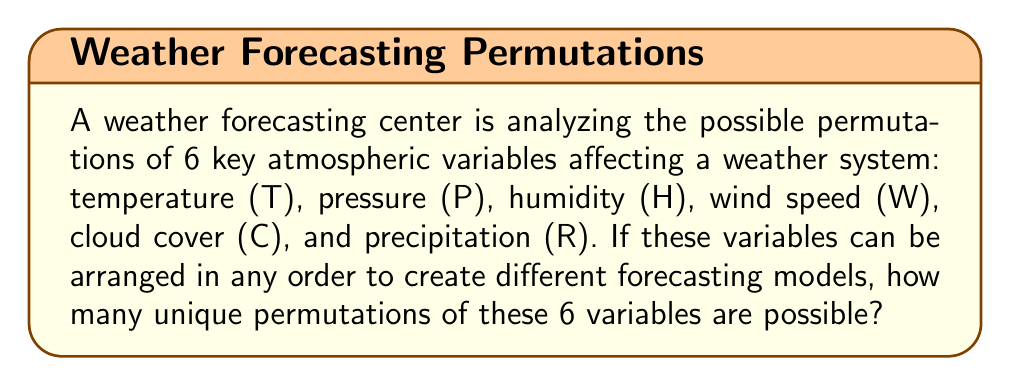Can you solve this math problem? To solve this problem, we need to use the concept of permutations from combinatorics. When we have a set of distinct objects and we want to arrange all of them in different orders, the number of permutations is given by the factorial of the number of objects.

In this case, we have 6 distinct atmospheric variables: T, P, H, W, C, and R.

The number of permutations of n distinct objects is given by:

$$ P(n) = n! $$

Where $n!$ represents the factorial of $n$.

For our problem, $n = 6$, so we need to calculate:

$$ P(6) = 6! $$

Let's expand this:

$$ 6! = 6 \times 5 \times 4 \times 3 \times 2 \times 1 $$

Multiplying these numbers:

$$ 6! = 720 $$

Therefore, there are 720 unique permutations of the 6 atmospheric variables.

This means that the weather forecasting center can create 720 different models by arranging these variables in different orders, potentially leading to a comprehensive analysis of the weather system from various perspectives.
Answer: 720 